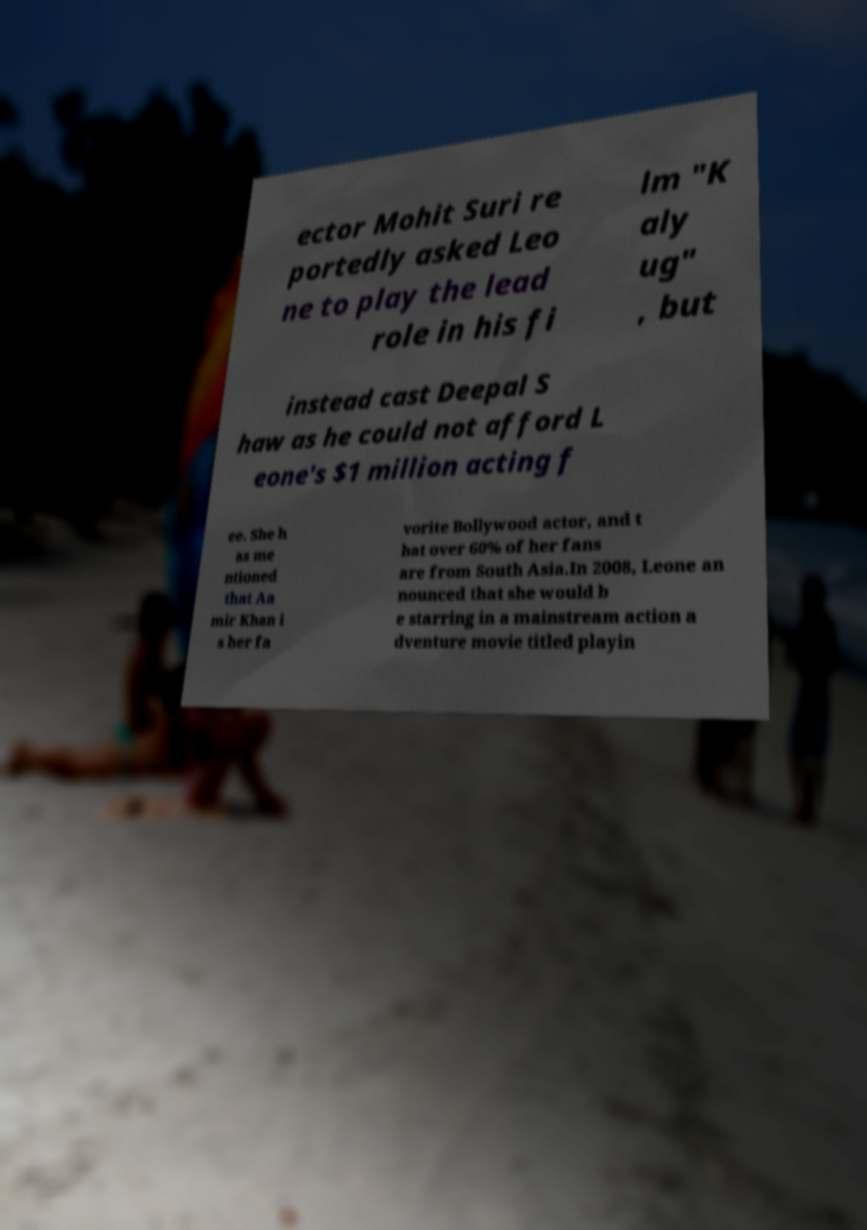What messages or text are displayed in this image? I need them in a readable, typed format. ector Mohit Suri re portedly asked Leo ne to play the lead role in his fi lm "K aly ug" , but instead cast Deepal S haw as he could not afford L eone's $1 million acting f ee. She h as me ntioned that Aa mir Khan i s her fa vorite Bollywood actor, and t hat over 60% of her fans are from South Asia.In 2008, Leone an nounced that she would b e starring in a mainstream action a dventure movie titled playin 